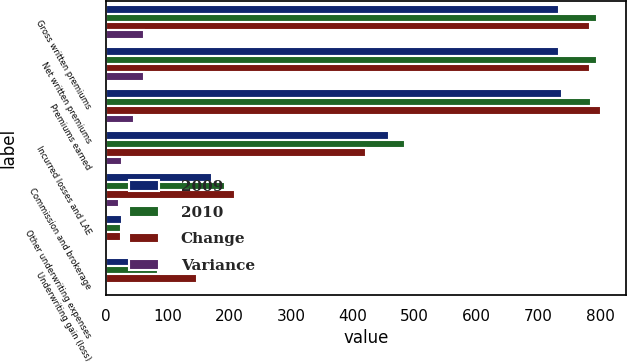Convert chart. <chart><loc_0><loc_0><loc_500><loc_500><stacked_bar_chart><ecel><fcel>Gross written premiums<fcel>Net written premiums<fcel>Premiums earned<fcel>Incurred losses and LAE<fcel>Commission and brokerage<fcel>Other underwriting expenses<fcel>Underwriting gain (loss)<nl><fcel>2009<fcel>733<fcel>733<fcel>738.4<fcel>457.9<fcel>171.1<fcel>26.4<fcel>83<nl><fcel>2010<fcel>794.8<fcel>795.1<fcel>784.6<fcel>484<fcel>192.1<fcel>24.6<fcel>83.9<nl><fcel>Change<fcel>783.4<fcel>783.1<fcel>801.2<fcel>420.3<fcel>208.9<fcel>24.2<fcel>147.8<nl><fcel>Variance<fcel>61.9<fcel>62<fcel>46.1<fcel>26.1<fcel>21<fcel>1.9<fcel>0.9<nl></chart> 